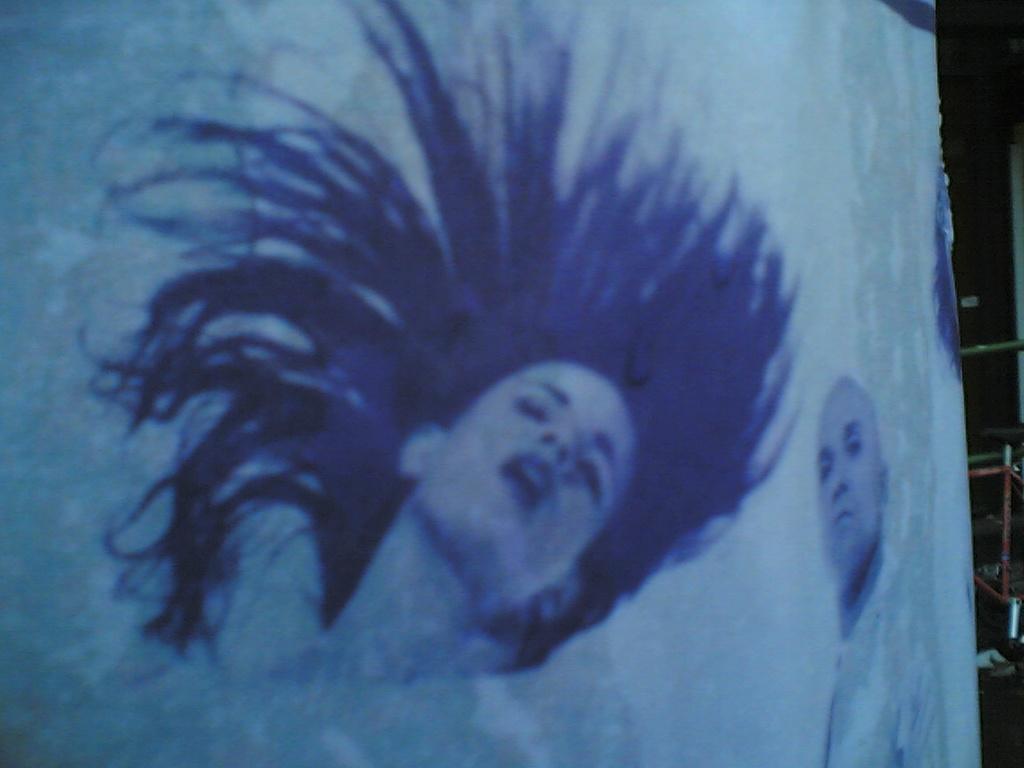Could you give a brief overview of what you see in this image? In this image there is a picture of a woman and a man on the banner. On the right side of the image there are metal rods. 